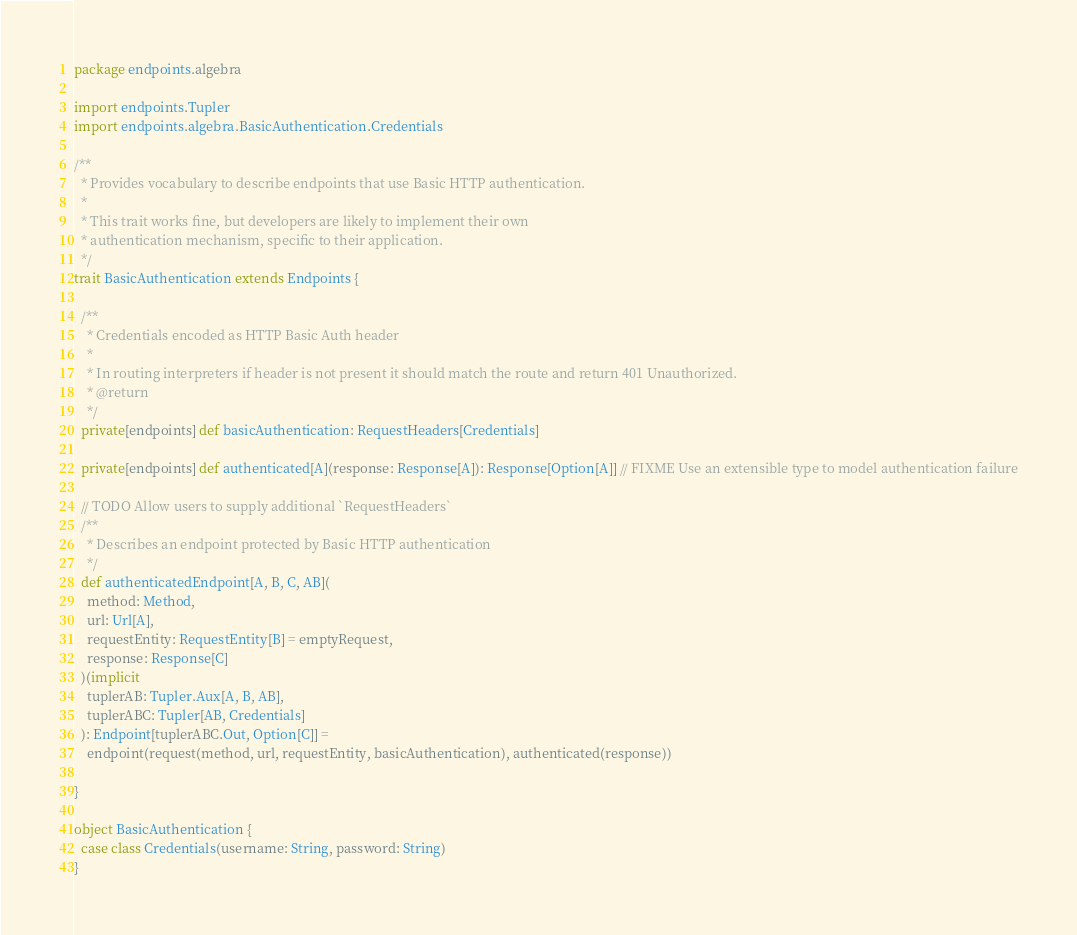<code> <loc_0><loc_0><loc_500><loc_500><_Scala_>package endpoints.algebra

import endpoints.Tupler
import endpoints.algebra.BasicAuthentication.Credentials

/**
  * Provides vocabulary to describe endpoints that use Basic HTTP authentication.
  *
  * This trait works fine, but developers are likely to implement their own
  * authentication mechanism, specific to their application.
  */
trait BasicAuthentication extends Endpoints {

  /**
    * Credentials encoded as HTTP Basic Auth header
    *
    * In routing interpreters if header is not present it should match the route and return 401 Unauthorized.
    * @return
    */
  private[endpoints] def basicAuthentication: RequestHeaders[Credentials]

  private[endpoints] def authenticated[A](response: Response[A]): Response[Option[A]] // FIXME Use an extensible type to model authentication failure

  // TODO Allow users to supply additional `RequestHeaders`
  /**
    * Describes an endpoint protected by Basic HTTP authentication
    */
  def authenticatedEndpoint[A, B, C, AB](
    method: Method,
    url: Url[A],
    requestEntity: RequestEntity[B] = emptyRequest,
    response: Response[C]
  )(implicit
    tuplerAB: Tupler.Aux[A, B, AB],
    tuplerABC: Tupler[AB, Credentials]
  ): Endpoint[tuplerABC.Out, Option[C]] =
    endpoint(request(method, url, requestEntity, basicAuthentication), authenticated(response))

}

object BasicAuthentication {
  case class Credentials(username: String, password: String)
}

</code> 